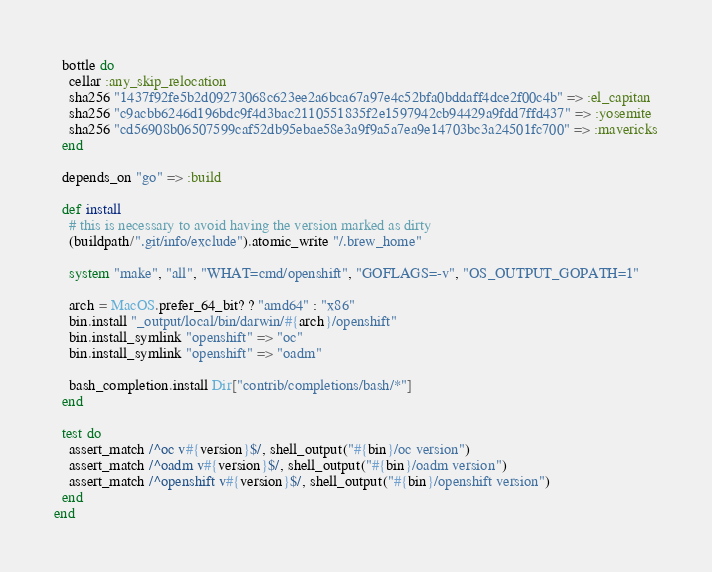Convert code to text. <code><loc_0><loc_0><loc_500><loc_500><_Ruby_>  bottle do
    cellar :any_skip_relocation
    sha256 "1437f92fe5b2d09273068c623ee2a6bca67a97e4c52bfa0bddaff4dce2f00c4b" => :el_capitan
    sha256 "c9acbb6246d196bdc9f4d3bac2110551835f2e1597942cb94429a9fdd7ffd437" => :yosemite
    sha256 "cd56908b06507599caf52db95ebae58e3a9f9a5a7ea9e14703bc3a24501fc700" => :mavericks
  end

  depends_on "go" => :build

  def install
    # this is necessary to avoid having the version marked as dirty
    (buildpath/".git/info/exclude").atomic_write "/.brew_home"

    system "make", "all", "WHAT=cmd/openshift", "GOFLAGS=-v", "OS_OUTPUT_GOPATH=1"

    arch = MacOS.prefer_64_bit? ? "amd64" : "x86"
    bin.install "_output/local/bin/darwin/#{arch}/openshift"
    bin.install_symlink "openshift" => "oc"
    bin.install_symlink "openshift" => "oadm"

    bash_completion.install Dir["contrib/completions/bash/*"]
  end

  test do
    assert_match /^oc v#{version}$/, shell_output("#{bin}/oc version")
    assert_match /^oadm v#{version}$/, shell_output("#{bin}/oadm version")
    assert_match /^openshift v#{version}$/, shell_output("#{bin}/openshift version")
  end
end
</code> 